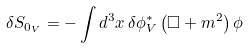<formula> <loc_0><loc_0><loc_500><loc_500>\delta S _ { 0 _ { V } } = - \int d ^ { 3 } x \, \delta \phi ^ { * } _ { V } \left ( \Box + m ^ { 2 } \right ) \phi</formula> 